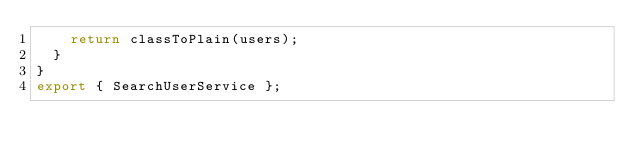Convert code to text. <code><loc_0><loc_0><loc_500><loc_500><_TypeScript_>    return classToPlain(users);
  }
}
export { SearchUserService };
</code> 